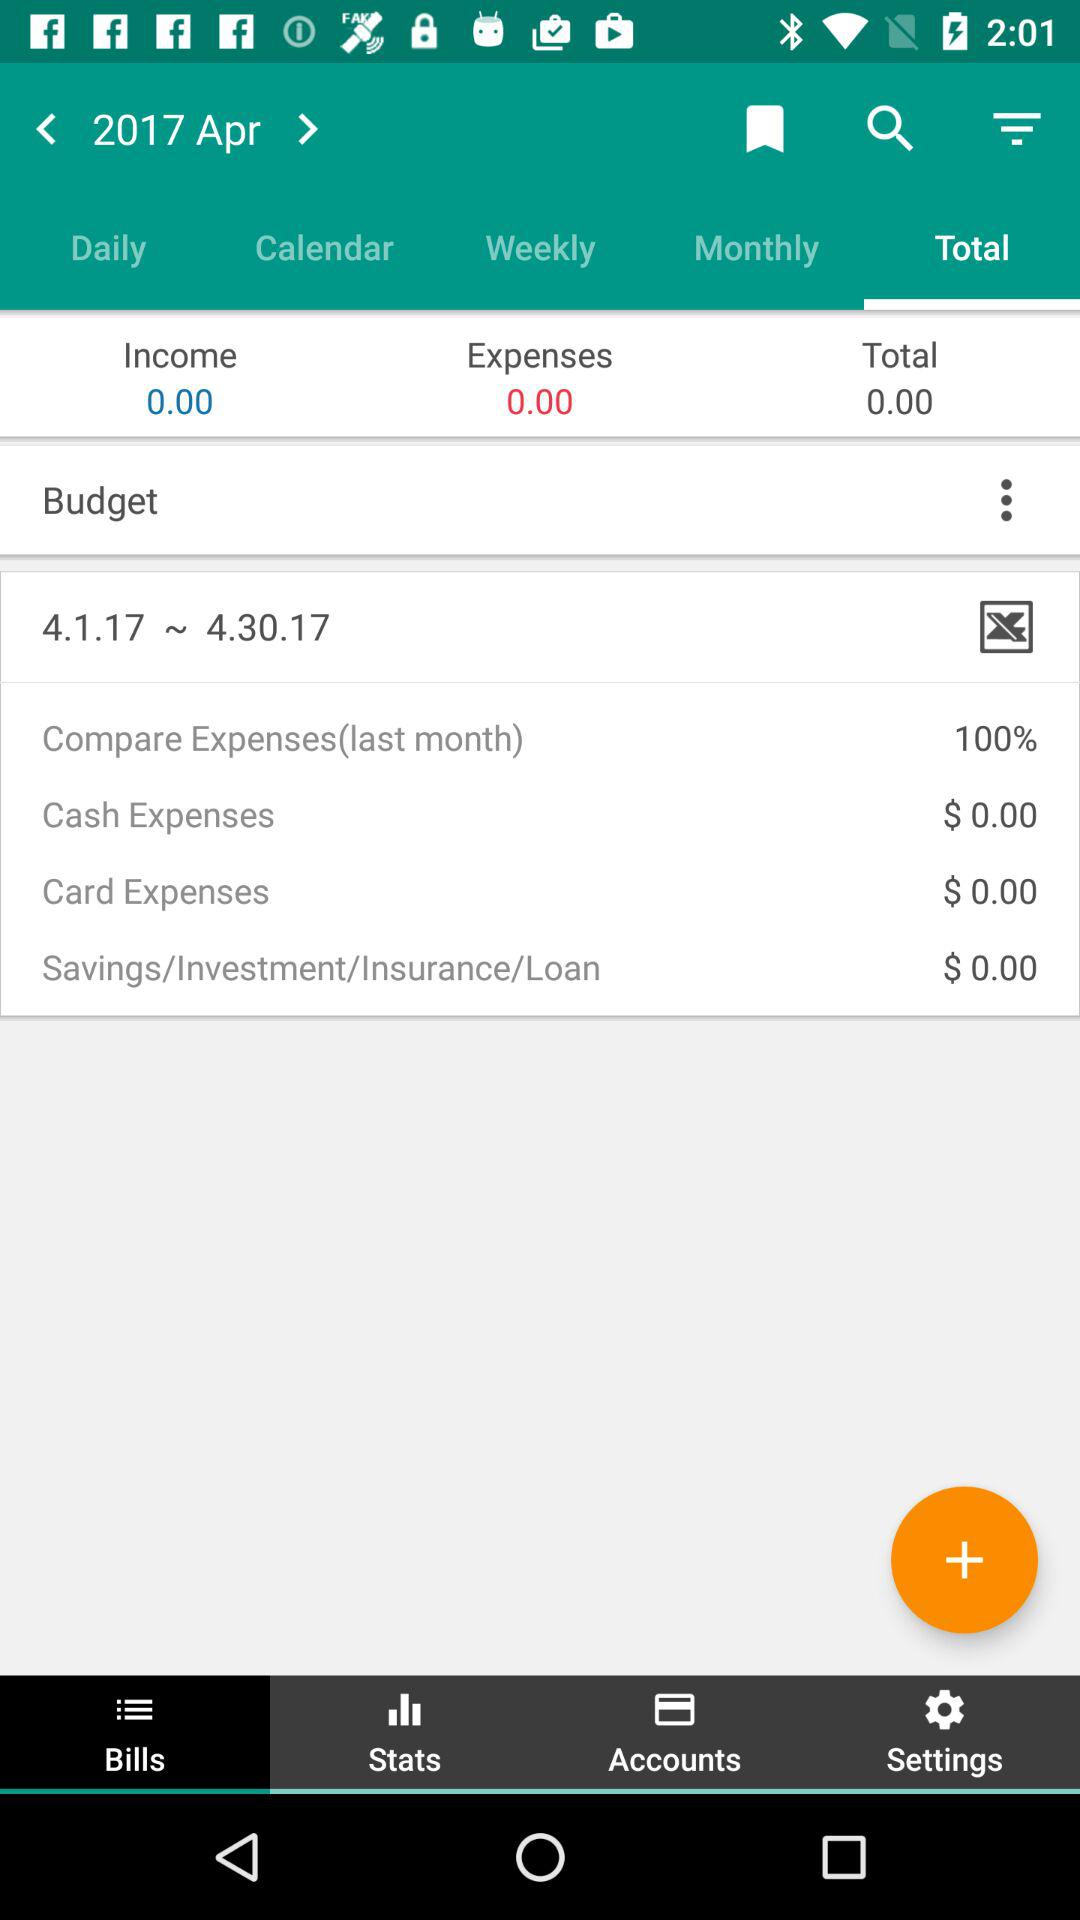How much was the card expense? The card expense was $0. 